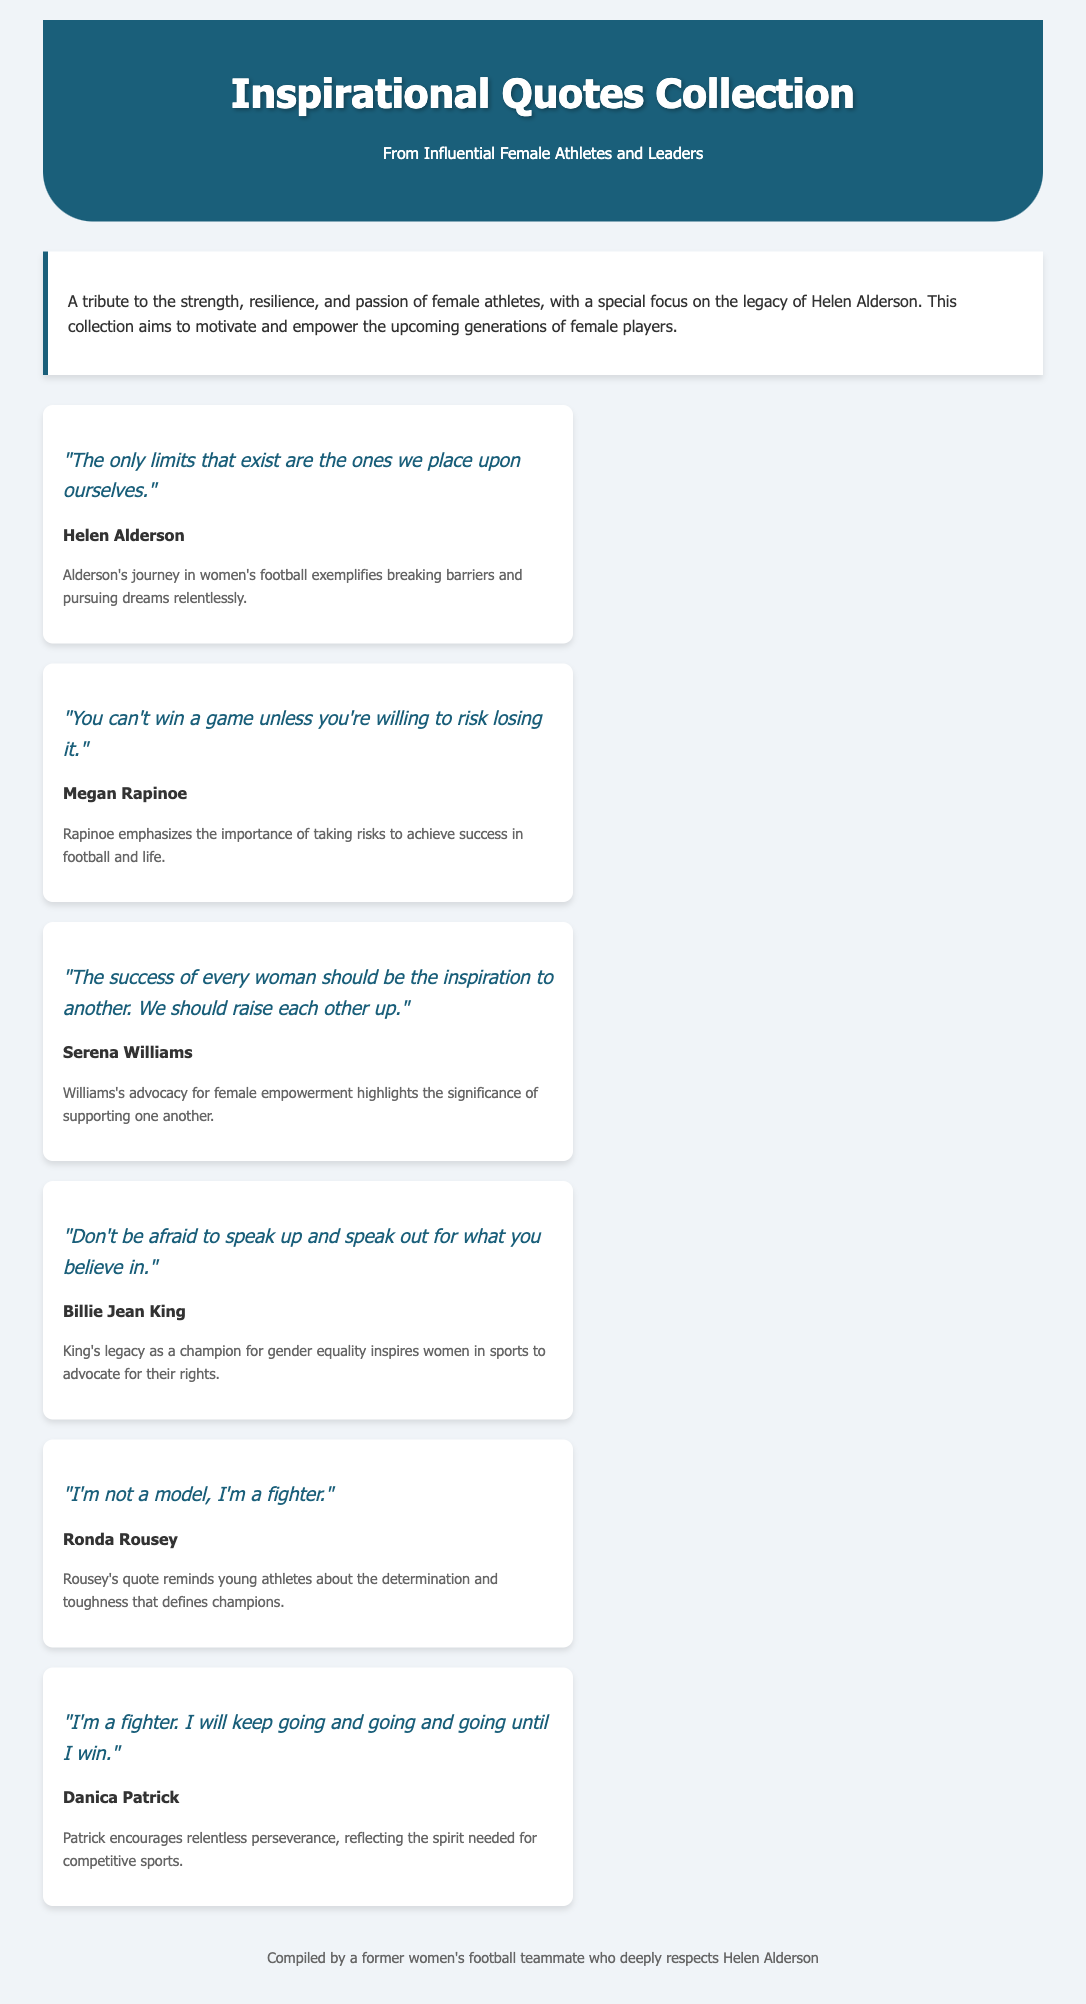What is the title of the document? The title of the document is presented prominently in the header section of the page.
Answer: Inspirational Quotes Collection Who is specifically highlighted in the introduction? The introduction mentions a particular individual who has made significant contributions to inspire female athletes.
Answer: Helen Alderson How many quotes are attributed to Helen Alderson in the document? The document contains one quote that is specifically attributed to Helen Alderson.
Answer: One Which athlete said, "You can't win a game unless you're willing to risk losing it"? This quote is attributed to a famous female football player known for her willingness to challenge norms and advocate for the sport.
Answer: Megan Rapinoe What is the main theme of Serena Williams' quote? Serena Williams' quote focuses on the importance of collective success and support among women.
Answer: Empowerment Which quote emphasizes the need for women to advocate for their beliefs? The document includes a powerful message from a tennis legend about standing up for one's convictions.
Answer: "Don't be afraid to speak up and speak out for what you believe in." What type of document is this? The structure and content are aimed at providing inspiration through quotes from notable figures focusing on a specific theme.
Answer: Catalog What color scheme is used in the header? The header features a particular color that stands out and complements the overall aesthetic of the document.
Answer: Dark blue 